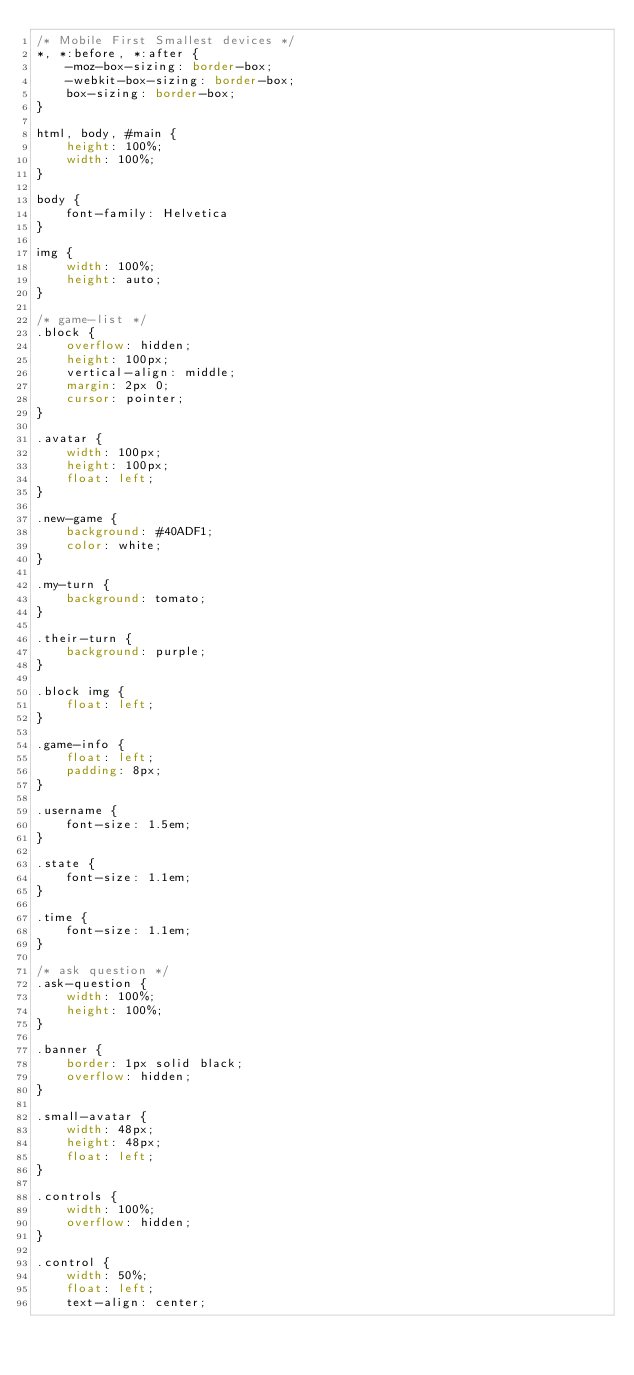Convert code to text. <code><loc_0><loc_0><loc_500><loc_500><_CSS_>/* Mobile First Smallest devices */
*, *:before, *:after {
    -moz-box-sizing: border-box;
    -webkit-box-sizing: border-box;
    box-sizing: border-box;
}

html, body, #main {
    height: 100%;
    width: 100%;
}

body {
    font-family: Helvetica
}

img {
    width: 100%;
    height: auto;
}

/* game-list */
.block {
    overflow: hidden;
    height: 100px;
    vertical-align: middle;
    margin: 2px 0;
    cursor: pointer;
}

.avatar {
    width: 100px;
    height: 100px;
    float: left;
}

.new-game {
    background: #40ADF1;
    color: white;
}

.my-turn {
    background: tomato;
}

.their-turn {
    background: purple;
}

.block img {
    float: left;    
}

.game-info {
    float: left;
    padding: 8px;
}

.username {
    font-size: 1.5em;
}

.state {
    font-size: 1.1em;
}

.time {
    font-size: 1.1em;
}

/* ask question */
.ask-question {
    width: 100%;
    height: 100%;
}

.banner {
    border: 1px solid black;
    overflow: hidden;
}

.small-avatar {
    width: 48px;
    height: 48px;
    float: left;
}

.controls {
    width: 100%;
    overflow: hidden;
}

.control {
    width: 50%; 
    float: left; 
    text-align: center; </code> 